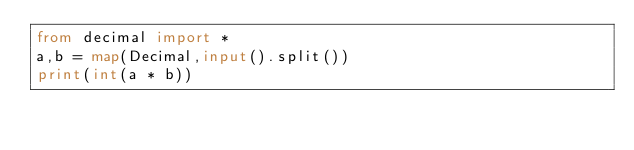Convert code to text. <code><loc_0><loc_0><loc_500><loc_500><_Python_>from decimal import *
a,b = map(Decimal,input().split())
print(int(a * b))</code> 